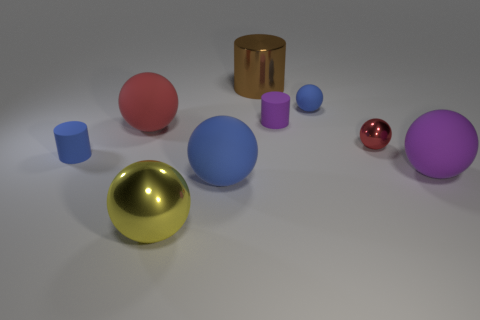There is a tiny purple object; does it have the same shape as the tiny blue matte thing that is left of the big yellow metallic object?
Give a very brief answer. Yes. Is there a tiny rubber object that has the same color as the tiny metal sphere?
Offer a terse response. No. How many spheres are either big brown things or big red things?
Your answer should be very brief. 1. Is there another object of the same shape as the big red rubber object?
Offer a terse response. Yes. What number of other objects are the same color as the tiny shiny sphere?
Your answer should be compact. 1. Are there fewer big metal objects that are behind the big blue sphere than blue metallic cylinders?
Offer a terse response. No. How many large cyan cylinders are there?
Offer a terse response. 0. What number of big brown cylinders have the same material as the big purple thing?
Keep it short and to the point. 0. How many objects are tiny rubber cylinders in front of the tiny shiny sphere or big red rubber spheres?
Your answer should be compact. 2. Are there fewer yellow things that are behind the tiny metal sphere than blue cylinders that are in front of the purple ball?
Ensure brevity in your answer.  No. 